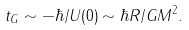Convert formula to latex. <formula><loc_0><loc_0><loc_500><loc_500>t _ { G } \sim - \hbar { / } U ( 0 ) \sim \hbar { R } / G M ^ { 2 } .</formula> 